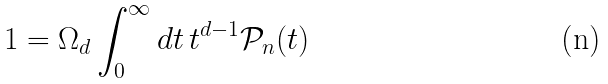Convert formula to latex. <formula><loc_0><loc_0><loc_500><loc_500>1 = \Omega _ { d } \int _ { 0 } ^ { \infty } d t \, t ^ { d - 1 } \mathcal { P } _ { n } ( t )</formula> 